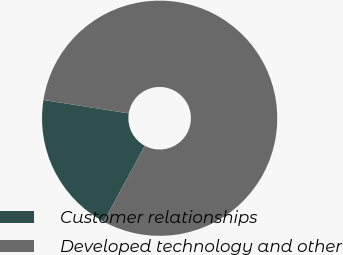Convert chart to OTSL. <chart><loc_0><loc_0><loc_500><loc_500><pie_chart><fcel>Customer relationships<fcel>Developed technology and other<nl><fcel>19.59%<fcel>80.41%<nl></chart> 